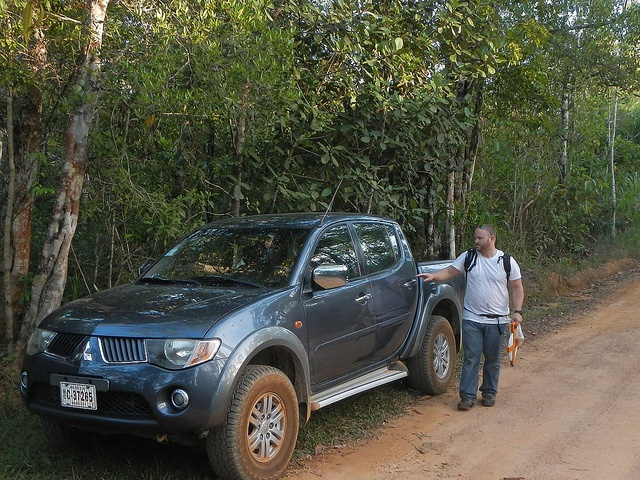Describe the objects in this image and their specific colors. I can see truck in tan, black, gray, blue, and darkgray tones, people in tan, gray, black, darkgray, and blue tones, and backpack in tan, black, gray, and darkblue tones in this image. 